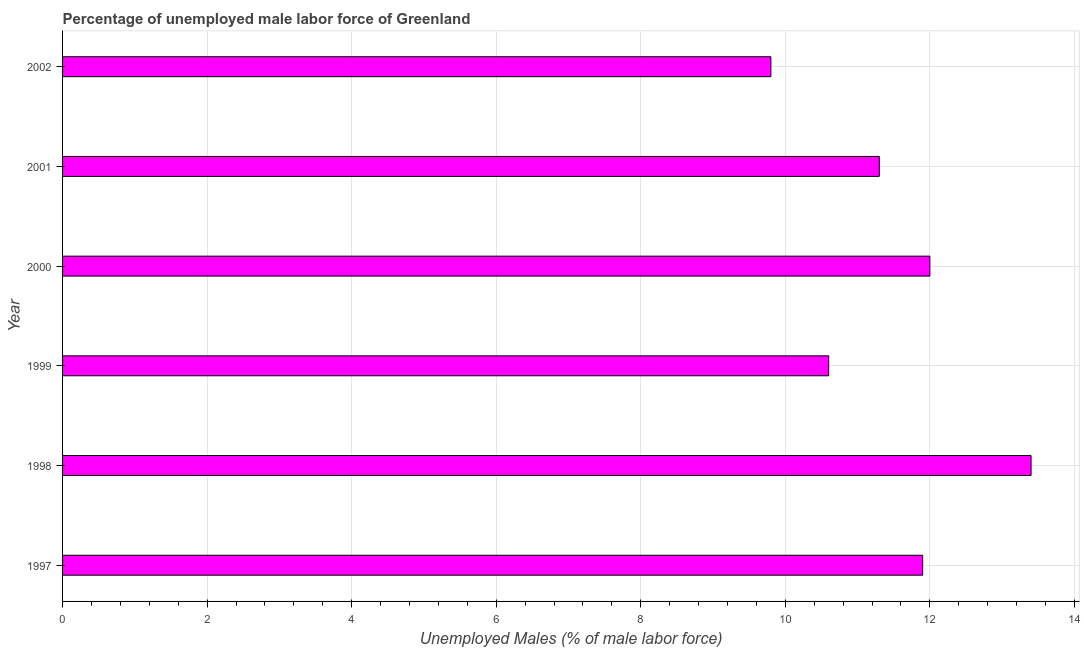Does the graph contain any zero values?
Your answer should be compact. No. What is the title of the graph?
Your answer should be compact. Percentage of unemployed male labor force of Greenland. What is the label or title of the X-axis?
Provide a short and direct response. Unemployed Males (% of male labor force). Across all years, what is the maximum total unemployed male labour force?
Your answer should be very brief. 13.4. Across all years, what is the minimum total unemployed male labour force?
Your response must be concise. 9.8. What is the sum of the total unemployed male labour force?
Give a very brief answer. 69. What is the difference between the total unemployed male labour force in 2000 and 2002?
Ensure brevity in your answer.  2.2. What is the average total unemployed male labour force per year?
Your answer should be compact. 11.5. What is the median total unemployed male labour force?
Provide a succinct answer. 11.6. What is the ratio of the total unemployed male labour force in 2000 to that in 2001?
Offer a terse response. 1.06. Is the total unemployed male labour force in 2001 less than that in 2002?
Offer a very short reply. No. Is the difference between the total unemployed male labour force in 1998 and 2001 greater than the difference between any two years?
Your answer should be very brief. No. What is the difference between the highest and the second highest total unemployed male labour force?
Keep it short and to the point. 1.4. Is the sum of the total unemployed male labour force in 2001 and 2002 greater than the maximum total unemployed male labour force across all years?
Make the answer very short. Yes. Are all the bars in the graph horizontal?
Give a very brief answer. Yes. How many years are there in the graph?
Ensure brevity in your answer.  6. What is the difference between two consecutive major ticks on the X-axis?
Offer a terse response. 2. Are the values on the major ticks of X-axis written in scientific E-notation?
Keep it short and to the point. No. What is the Unemployed Males (% of male labor force) of 1997?
Your answer should be compact. 11.9. What is the Unemployed Males (% of male labor force) of 1998?
Your response must be concise. 13.4. What is the Unemployed Males (% of male labor force) of 1999?
Make the answer very short. 10.6. What is the Unemployed Males (% of male labor force) in 2000?
Ensure brevity in your answer.  12. What is the Unemployed Males (% of male labor force) in 2001?
Provide a succinct answer. 11.3. What is the Unemployed Males (% of male labor force) in 2002?
Offer a very short reply. 9.8. What is the difference between the Unemployed Males (% of male labor force) in 1997 and 1998?
Ensure brevity in your answer.  -1.5. What is the difference between the Unemployed Males (% of male labor force) in 1997 and 2001?
Your response must be concise. 0.6. What is the difference between the Unemployed Males (% of male labor force) in 1997 and 2002?
Make the answer very short. 2.1. What is the difference between the Unemployed Males (% of male labor force) in 1998 and 1999?
Keep it short and to the point. 2.8. What is the difference between the Unemployed Males (% of male labor force) in 1998 and 2000?
Give a very brief answer. 1.4. What is the difference between the Unemployed Males (% of male labor force) in 1999 and 2000?
Ensure brevity in your answer.  -1.4. What is the difference between the Unemployed Males (% of male labor force) in 2000 and 2001?
Ensure brevity in your answer.  0.7. What is the ratio of the Unemployed Males (% of male labor force) in 1997 to that in 1998?
Your response must be concise. 0.89. What is the ratio of the Unemployed Males (% of male labor force) in 1997 to that in 1999?
Your answer should be very brief. 1.12. What is the ratio of the Unemployed Males (% of male labor force) in 1997 to that in 2001?
Keep it short and to the point. 1.05. What is the ratio of the Unemployed Males (% of male labor force) in 1997 to that in 2002?
Your response must be concise. 1.21. What is the ratio of the Unemployed Males (% of male labor force) in 1998 to that in 1999?
Your response must be concise. 1.26. What is the ratio of the Unemployed Males (% of male labor force) in 1998 to that in 2000?
Your answer should be compact. 1.12. What is the ratio of the Unemployed Males (% of male labor force) in 1998 to that in 2001?
Provide a short and direct response. 1.19. What is the ratio of the Unemployed Males (% of male labor force) in 1998 to that in 2002?
Provide a short and direct response. 1.37. What is the ratio of the Unemployed Males (% of male labor force) in 1999 to that in 2000?
Offer a terse response. 0.88. What is the ratio of the Unemployed Males (% of male labor force) in 1999 to that in 2001?
Make the answer very short. 0.94. What is the ratio of the Unemployed Males (% of male labor force) in 1999 to that in 2002?
Your response must be concise. 1.08. What is the ratio of the Unemployed Males (% of male labor force) in 2000 to that in 2001?
Keep it short and to the point. 1.06. What is the ratio of the Unemployed Males (% of male labor force) in 2000 to that in 2002?
Offer a very short reply. 1.22. What is the ratio of the Unemployed Males (% of male labor force) in 2001 to that in 2002?
Your response must be concise. 1.15. 